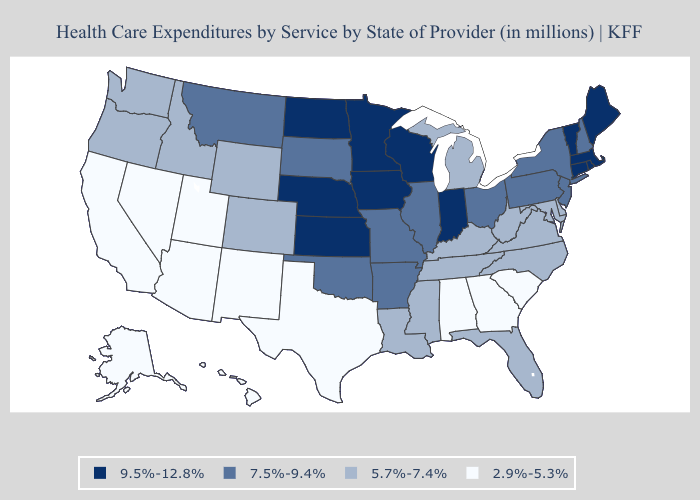Name the states that have a value in the range 9.5%-12.8%?
Write a very short answer. Connecticut, Indiana, Iowa, Kansas, Maine, Massachusetts, Minnesota, Nebraska, North Dakota, Rhode Island, Vermont, Wisconsin. Name the states that have a value in the range 7.5%-9.4%?
Concise answer only. Arkansas, Illinois, Missouri, Montana, New Hampshire, New Jersey, New York, Ohio, Oklahoma, Pennsylvania, South Dakota. What is the lowest value in the West?
Write a very short answer. 2.9%-5.3%. What is the value of Nevada?
Give a very brief answer. 2.9%-5.3%. What is the lowest value in the MidWest?
Keep it brief. 5.7%-7.4%. What is the lowest value in the USA?
Short answer required. 2.9%-5.3%. Does California have the lowest value in the USA?
Short answer required. Yes. Name the states that have a value in the range 9.5%-12.8%?
Be succinct. Connecticut, Indiana, Iowa, Kansas, Maine, Massachusetts, Minnesota, Nebraska, North Dakota, Rhode Island, Vermont, Wisconsin. Does New Mexico have a lower value than Minnesota?
Concise answer only. Yes. Name the states that have a value in the range 2.9%-5.3%?
Answer briefly. Alabama, Alaska, Arizona, California, Georgia, Hawaii, Nevada, New Mexico, South Carolina, Texas, Utah. Does the map have missing data?
Quick response, please. No. Name the states that have a value in the range 9.5%-12.8%?
Write a very short answer. Connecticut, Indiana, Iowa, Kansas, Maine, Massachusetts, Minnesota, Nebraska, North Dakota, Rhode Island, Vermont, Wisconsin. What is the value of Maine?
Answer briefly. 9.5%-12.8%. Does the map have missing data?
Write a very short answer. No. 